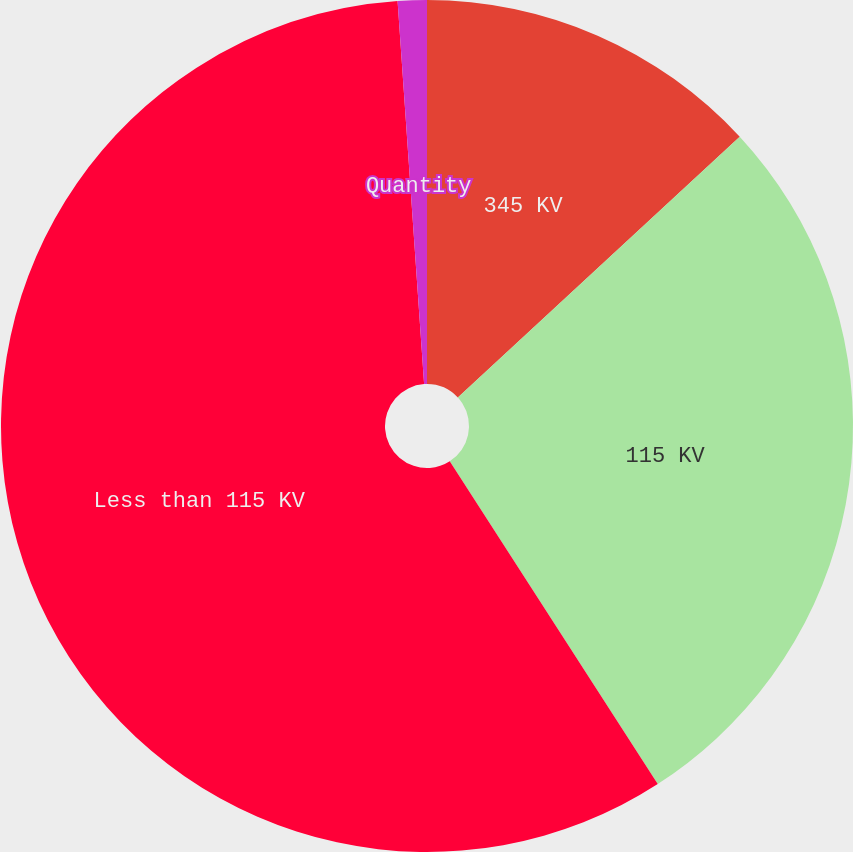Convert chart to OTSL. <chart><loc_0><loc_0><loc_500><loc_500><pie_chart><fcel>345 KV<fcel>115 KV<fcel>Less than 115 KV<fcel>Quantity<nl><fcel>13.12%<fcel>27.77%<fcel>58.01%<fcel>1.1%<nl></chart> 